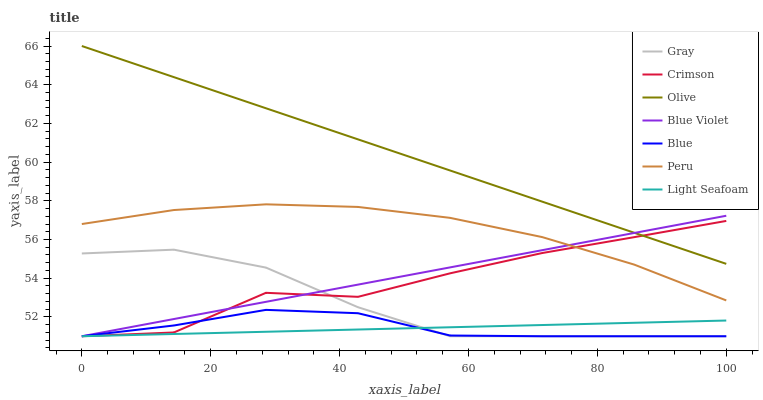Does Light Seafoam have the minimum area under the curve?
Answer yes or no. Yes. Does Olive have the maximum area under the curve?
Answer yes or no. Yes. Does Gray have the minimum area under the curve?
Answer yes or no. No. Does Gray have the maximum area under the curve?
Answer yes or no. No. Is Light Seafoam the smoothest?
Answer yes or no. Yes. Is Crimson the roughest?
Answer yes or no. Yes. Is Gray the smoothest?
Answer yes or no. No. Is Gray the roughest?
Answer yes or no. No. Does Blue have the lowest value?
Answer yes or no. Yes. Does Olive have the lowest value?
Answer yes or no. No. Does Olive have the highest value?
Answer yes or no. Yes. Does Gray have the highest value?
Answer yes or no. No. Is Blue less than Olive?
Answer yes or no. Yes. Is Olive greater than Gray?
Answer yes or no. Yes. Does Gray intersect Blue Violet?
Answer yes or no. Yes. Is Gray less than Blue Violet?
Answer yes or no. No. Is Gray greater than Blue Violet?
Answer yes or no. No. Does Blue intersect Olive?
Answer yes or no. No. 